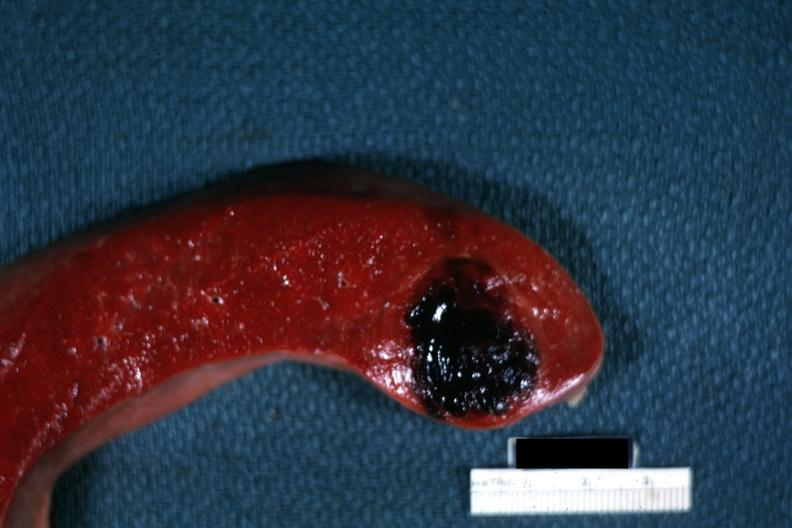s serous cystadenoma present?
Answer the question using a single word or phrase. No 